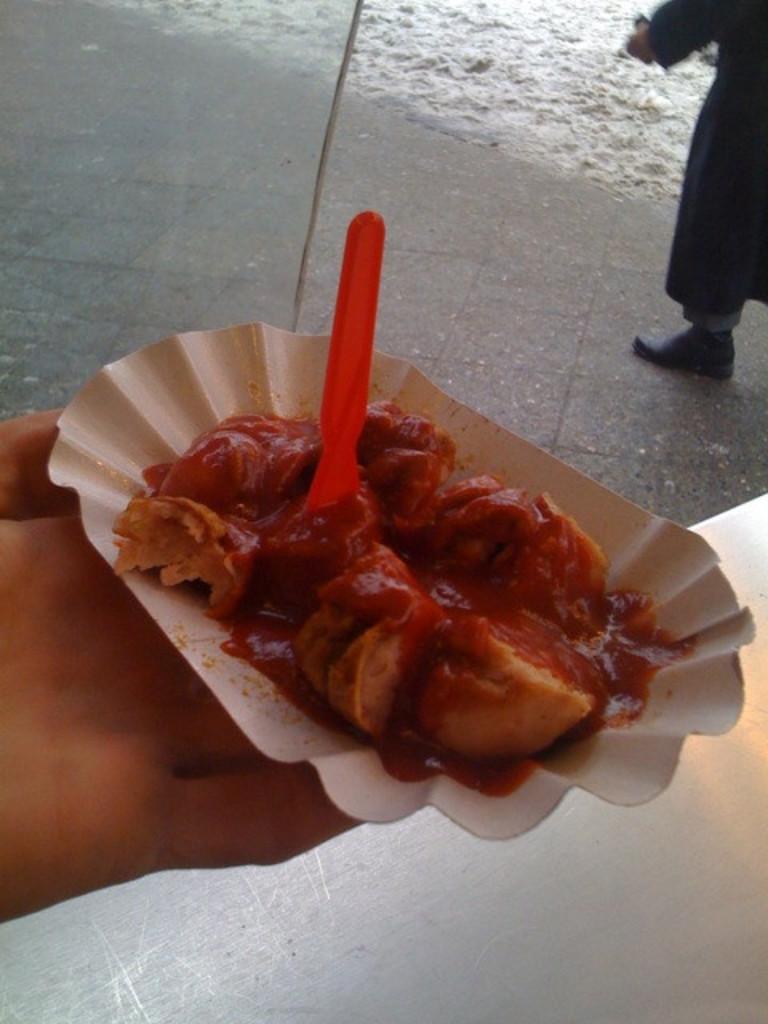How would you summarize this image in a sentence or two? In the foreground I can see a person is holding a food plate in hand and another person is standing on the road in front of water. This image is taken may be during a day on the road. 